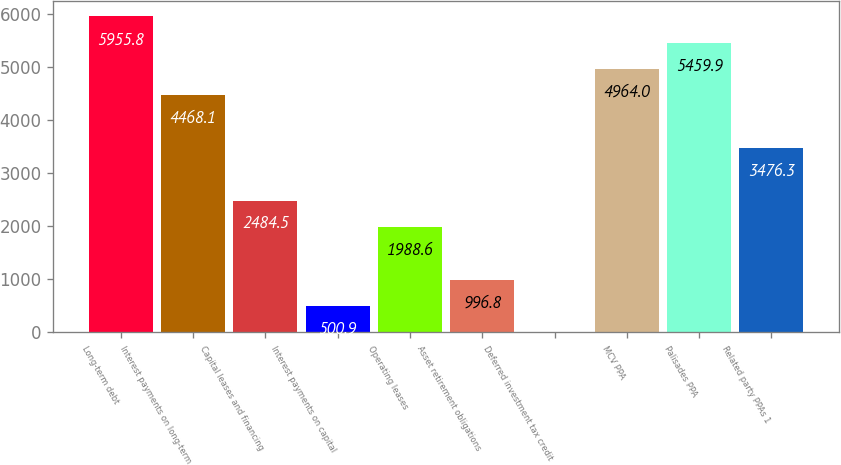Convert chart to OTSL. <chart><loc_0><loc_0><loc_500><loc_500><bar_chart><fcel>Long-term debt<fcel>Interest payments on long-term<fcel>Capital leases and financing<fcel>Interest payments on capital<fcel>Operating leases<fcel>Asset retirement obligations<fcel>Deferred investment tax credit<fcel>MCV PPA<fcel>Palisades PPA<fcel>Related party PPAs 1<nl><fcel>5955.8<fcel>4468.1<fcel>2484.5<fcel>500.9<fcel>1988.6<fcel>996.8<fcel>5<fcel>4964<fcel>5459.9<fcel>3476.3<nl></chart> 